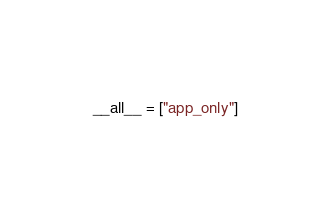Convert code to text. <code><loc_0><loc_0><loc_500><loc_500><_Python_>__all__ = ["app_only"]</code> 